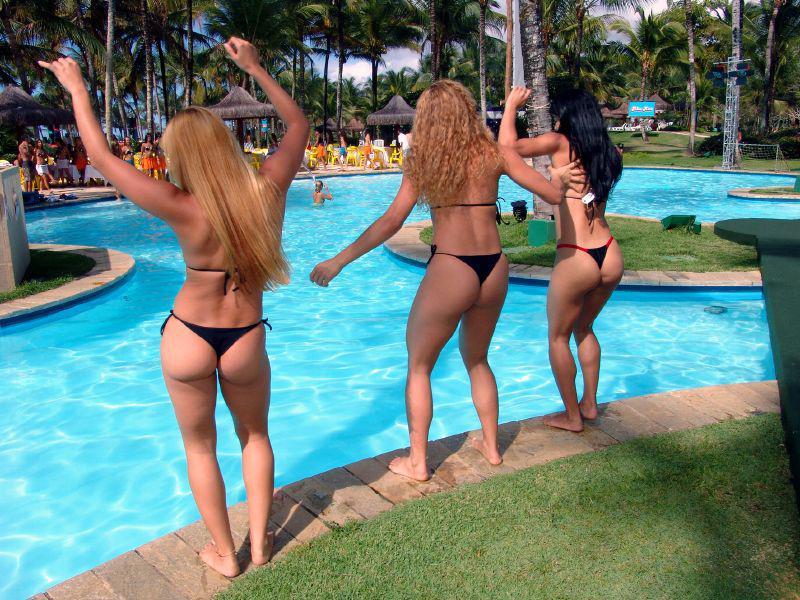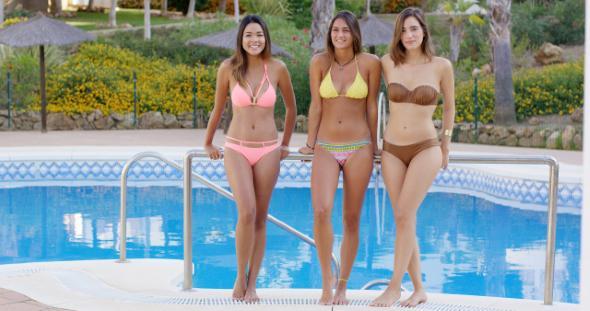The first image is the image on the left, the second image is the image on the right. For the images shown, is this caption "In the left image, women in bikinis are sitting on the edge of the water with their feet dangling in or above the water" true? Answer yes or no. No. 